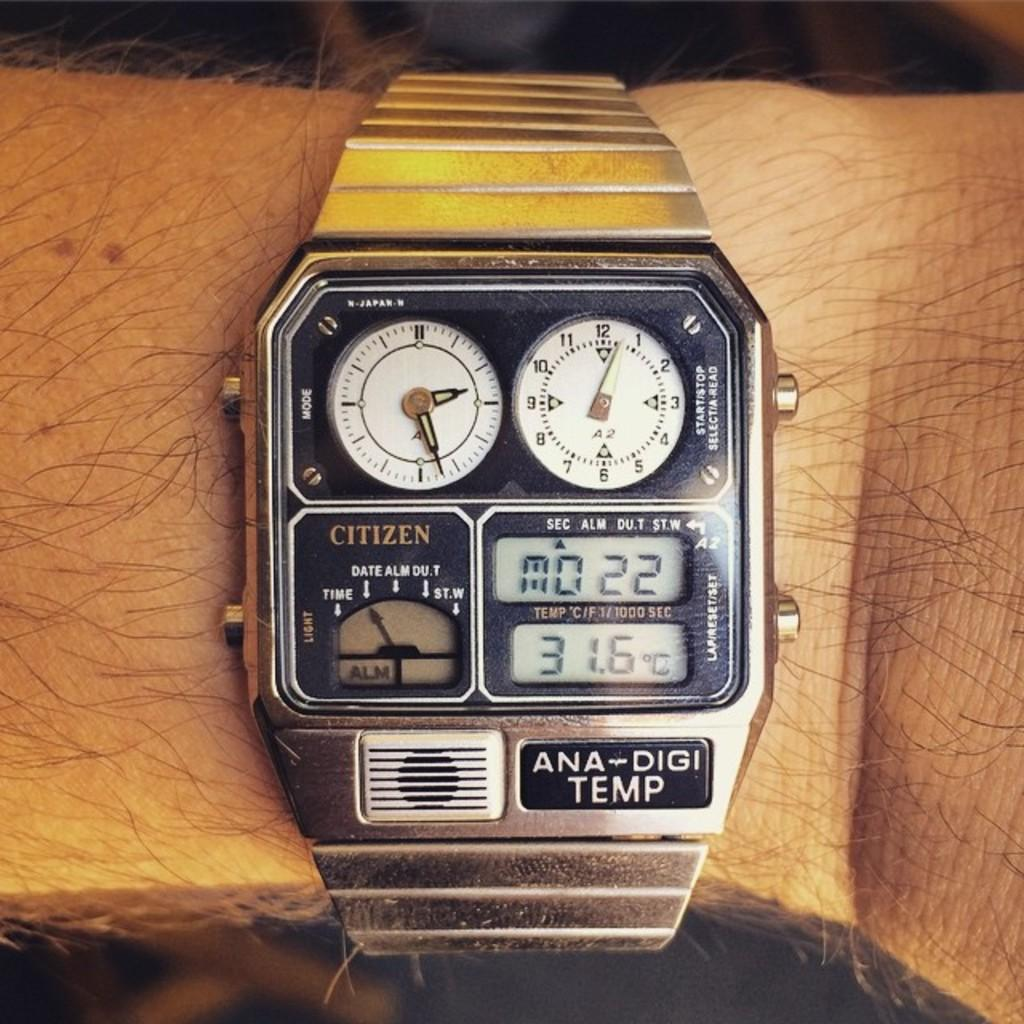What part of a person is visible in the image? There is a person's hand in the image. What accessory is on the person's hand? The person's hand has a watch. Can you describe the background of the image? The background of the image is blurred. What type of advice can be heard from the lizards in the image? There are no lizards present in the image, so no advice can be heard from them. 